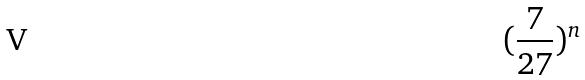Convert formula to latex. <formula><loc_0><loc_0><loc_500><loc_500>( \frac { 7 } { 2 7 } ) ^ { n }</formula> 